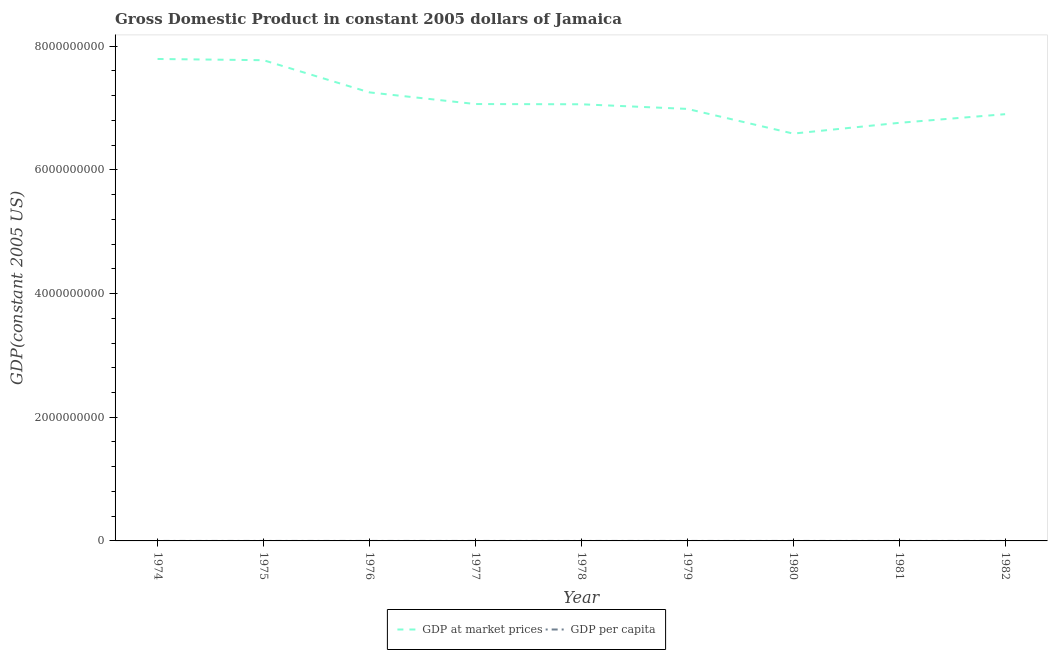Does the line corresponding to gdp at market prices intersect with the line corresponding to gdp per capita?
Provide a short and direct response. No. What is the gdp per capita in 1978?
Provide a succinct answer. 3393.74. Across all years, what is the maximum gdp at market prices?
Keep it short and to the point. 7.79e+09. Across all years, what is the minimum gdp at market prices?
Your answer should be very brief. 6.59e+09. In which year was the gdp at market prices maximum?
Make the answer very short. 1974. In which year was the gdp per capita minimum?
Make the answer very short. 1980. What is the total gdp per capita in the graph?
Keep it short and to the point. 3.08e+04. What is the difference between the gdp per capita in 1977 and that in 1978?
Offer a very short reply. 36.3. What is the difference between the gdp at market prices in 1981 and the gdp per capita in 1978?
Give a very brief answer. 6.76e+09. What is the average gdp at market prices per year?
Your response must be concise. 7.13e+09. In the year 1974, what is the difference between the gdp at market prices and gdp per capita?
Your response must be concise. 7.79e+09. In how many years, is the gdp at market prices greater than 7600000000 US$?
Your answer should be very brief. 2. What is the ratio of the gdp at market prices in 1977 to that in 1981?
Your answer should be compact. 1.04. Is the gdp per capita in 1977 less than that in 1979?
Provide a short and direct response. No. What is the difference between the highest and the second highest gdp per capita?
Your answer should be very brief. 62.83. What is the difference between the highest and the lowest gdp per capita?
Make the answer very short. 836.3. Is the sum of the gdp at market prices in 1976 and 1979 greater than the maximum gdp per capita across all years?
Offer a terse response. Yes. Does the gdp per capita monotonically increase over the years?
Your response must be concise. No. Is the gdp per capita strictly greater than the gdp at market prices over the years?
Offer a terse response. No. How many lines are there?
Make the answer very short. 2. What is the difference between two consecutive major ticks on the Y-axis?
Provide a short and direct response. 2.00e+09. Are the values on the major ticks of Y-axis written in scientific E-notation?
Provide a succinct answer. No. How are the legend labels stacked?
Offer a very short reply. Horizontal. What is the title of the graph?
Provide a succinct answer. Gross Domestic Product in constant 2005 dollars of Jamaica. What is the label or title of the X-axis?
Offer a terse response. Year. What is the label or title of the Y-axis?
Keep it short and to the point. GDP(constant 2005 US). What is the GDP(constant 2005 US) in GDP at market prices in 1974?
Your answer should be compact. 7.79e+09. What is the GDP(constant 2005 US) in GDP per capita in 1974?
Provide a succinct answer. 3923.99. What is the GDP(constant 2005 US) in GDP at market prices in 1975?
Provide a short and direct response. 7.77e+09. What is the GDP(constant 2005 US) of GDP per capita in 1975?
Your answer should be compact. 3861.15. What is the GDP(constant 2005 US) in GDP at market prices in 1976?
Provide a short and direct response. 7.25e+09. What is the GDP(constant 2005 US) in GDP per capita in 1976?
Keep it short and to the point. 3558.98. What is the GDP(constant 2005 US) of GDP at market prices in 1977?
Your answer should be compact. 7.06e+09. What is the GDP(constant 2005 US) of GDP per capita in 1977?
Provide a short and direct response. 3430.04. What is the GDP(constant 2005 US) in GDP at market prices in 1978?
Ensure brevity in your answer.  7.06e+09. What is the GDP(constant 2005 US) of GDP per capita in 1978?
Offer a terse response. 3393.74. What is the GDP(constant 2005 US) of GDP at market prices in 1979?
Your response must be concise. 6.99e+09. What is the GDP(constant 2005 US) in GDP per capita in 1979?
Provide a short and direct response. 3319.73. What is the GDP(constant 2005 US) of GDP at market prices in 1980?
Provide a succinct answer. 6.59e+09. What is the GDP(constant 2005 US) of GDP per capita in 1980?
Offer a terse response. 3087.69. What is the GDP(constant 2005 US) in GDP at market prices in 1981?
Keep it short and to the point. 6.76e+09. What is the GDP(constant 2005 US) in GDP per capita in 1981?
Your answer should be compact. 3126.24. What is the GDP(constant 2005 US) in GDP at market prices in 1982?
Offer a very short reply. 6.90e+09. What is the GDP(constant 2005 US) in GDP per capita in 1982?
Offer a very short reply. 3136.11. Across all years, what is the maximum GDP(constant 2005 US) of GDP at market prices?
Give a very brief answer. 7.79e+09. Across all years, what is the maximum GDP(constant 2005 US) of GDP per capita?
Your response must be concise. 3923.99. Across all years, what is the minimum GDP(constant 2005 US) in GDP at market prices?
Your response must be concise. 6.59e+09. Across all years, what is the minimum GDP(constant 2005 US) of GDP per capita?
Keep it short and to the point. 3087.69. What is the total GDP(constant 2005 US) of GDP at market prices in the graph?
Give a very brief answer. 6.42e+1. What is the total GDP(constant 2005 US) of GDP per capita in the graph?
Provide a short and direct response. 3.08e+04. What is the difference between the GDP(constant 2005 US) in GDP at market prices in 1974 and that in 1975?
Your answer should be very brief. 2.00e+07. What is the difference between the GDP(constant 2005 US) in GDP per capita in 1974 and that in 1975?
Provide a succinct answer. 62.83. What is the difference between the GDP(constant 2005 US) of GDP at market prices in 1974 and that in 1976?
Provide a succinct answer. 5.40e+08. What is the difference between the GDP(constant 2005 US) in GDP per capita in 1974 and that in 1976?
Your answer should be very brief. 365.01. What is the difference between the GDP(constant 2005 US) of GDP at market prices in 1974 and that in 1977?
Make the answer very short. 7.29e+08. What is the difference between the GDP(constant 2005 US) in GDP per capita in 1974 and that in 1977?
Keep it short and to the point. 493.95. What is the difference between the GDP(constant 2005 US) of GDP at market prices in 1974 and that in 1978?
Make the answer very short. 7.32e+08. What is the difference between the GDP(constant 2005 US) in GDP per capita in 1974 and that in 1978?
Offer a terse response. 530.25. What is the difference between the GDP(constant 2005 US) of GDP at market prices in 1974 and that in 1979?
Offer a terse response. 8.07e+08. What is the difference between the GDP(constant 2005 US) in GDP per capita in 1974 and that in 1979?
Your response must be concise. 604.26. What is the difference between the GDP(constant 2005 US) in GDP at market prices in 1974 and that in 1980?
Make the answer very short. 1.21e+09. What is the difference between the GDP(constant 2005 US) of GDP per capita in 1974 and that in 1980?
Ensure brevity in your answer.  836.3. What is the difference between the GDP(constant 2005 US) of GDP at market prices in 1974 and that in 1981?
Make the answer very short. 1.03e+09. What is the difference between the GDP(constant 2005 US) in GDP per capita in 1974 and that in 1981?
Provide a succinct answer. 797.75. What is the difference between the GDP(constant 2005 US) of GDP at market prices in 1974 and that in 1982?
Make the answer very short. 8.93e+08. What is the difference between the GDP(constant 2005 US) of GDP per capita in 1974 and that in 1982?
Your answer should be very brief. 787.88. What is the difference between the GDP(constant 2005 US) of GDP at market prices in 1975 and that in 1976?
Offer a very short reply. 5.20e+08. What is the difference between the GDP(constant 2005 US) in GDP per capita in 1975 and that in 1976?
Ensure brevity in your answer.  302.17. What is the difference between the GDP(constant 2005 US) of GDP at market prices in 1975 and that in 1977?
Ensure brevity in your answer.  7.09e+08. What is the difference between the GDP(constant 2005 US) of GDP per capita in 1975 and that in 1977?
Provide a succinct answer. 431.12. What is the difference between the GDP(constant 2005 US) of GDP at market prices in 1975 and that in 1978?
Make the answer very short. 7.12e+08. What is the difference between the GDP(constant 2005 US) of GDP per capita in 1975 and that in 1978?
Provide a succinct answer. 467.41. What is the difference between the GDP(constant 2005 US) in GDP at market prices in 1975 and that in 1979?
Provide a succinct answer. 7.87e+08. What is the difference between the GDP(constant 2005 US) of GDP per capita in 1975 and that in 1979?
Provide a short and direct response. 541.42. What is the difference between the GDP(constant 2005 US) in GDP at market prices in 1975 and that in 1980?
Your response must be concise. 1.19e+09. What is the difference between the GDP(constant 2005 US) of GDP per capita in 1975 and that in 1980?
Provide a succinct answer. 773.47. What is the difference between the GDP(constant 2005 US) of GDP at market prices in 1975 and that in 1981?
Offer a very short reply. 1.01e+09. What is the difference between the GDP(constant 2005 US) in GDP per capita in 1975 and that in 1981?
Your response must be concise. 734.91. What is the difference between the GDP(constant 2005 US) of GDP at market prices in 1975 and that in 1982?
Make the answer very short. 8.73e+08. What is the difference between the GDP(constant 2005 US) of GDP per capita in 1975 and that in 1982?
Your response must be concise. 725.05. What is the difference between the GDP(constant 2005 US) in GDP at market prices in 1976 and that in 1977?
Offer a very short reply. 1.88e+08. What is the difference between the GDP(constant 2005 US) in GDP per capita in 1976 and that in 1977?
Provide a short and direct response. 128.94. What is the difference between the GDP(constant 2005 US) in GDP at market prices in 1976 and that in 1978?
Provide a succinct answer. 1.92e+08. What is the difference between the GDP(constant 2005 US) in GDP per capita in 1976 and that in 1978?
Offer a very short reply. 165.24. What is the difference between the GDP(constant 2005 US) of GDP at market prices in 1976 and that in 1979?
Your response must be concise. 2.67e+08. What is the difference between the GDP(constant 2005 US) of GDP per capita in 1976 and that in 1979?
Offer a very short reply. 239.25. What is the difference between the GDP(constant 2005 US) in GDP at market prices in 1976 and that in 1980?
Your answer should be compact. 6.66e+08. What is the difference between the GDP(constant 2005 US) of GDP per capita in 1976 and that in 1980?
Provide a short and direct response. 471.29. What is the difference between the GDP(constant 2005 US) in GDP at market prices in 1976 and that in 1981?
Your answer should be compact. 4.92e+08. What is the difference between the GDP(constant 2005 US) in GDP per capita in 1976 and that in 1981?
Make the answer very short. 432.74. What is the difference between the GDP(constant 2005 US) of GDP at market prices in 1976 and that in 1982?
Give a very brief answer. 3.52e+08. What is the difference between the GDP(constant 2005 US) of GDP per capita in 1976 and that in 1982?
Make the answer very short. 422.87. What is the difference between the GDP(constant 2005 US) of GDP at market prices in 1977 and that in 1978?
Make the answer very short. 3.79e+06. What is the difference between the GDP(constant 2005 US) of GDP per capita in 1977 and that in 1978?
Make the answer very short. 36.3. What is the difference between the GDP(constant 2005 US) in GDP at market prices in 1977 and that in 1979?
Your answer should be very brief. 7.86e+07. What is the difference between the GDP(constant 2005 US) of GDP per capita in 1977 and that in 1979?
Offer a very short reply. 110.31. What is the difference between the GDP(constant 2005 US) in GDP at market prices in 1977 and that in 1980?
Ensure brevity in your answer.  4.78e+08. What is the difference between the GDP(constant 2005 US) in GDP per capita in 1977 and that in 1980?
Make the answer very short. 342.35. What is the difference between the GDP(constant 2005 US) in GDP at market prices in 1977 and that in 1981?
Offer a very short reply. 3.04e+08. What is the difference between the GDP(constant 2005 US) in GDP per capita in 1977 and that in 1981?
Make the answer very short. 303.8. What is the difference between the GDP(constant 2005 US) of GDP at market prices in 1977 and that in 1982?
Provide a short and direct response. 1.64e+08. What is the difference between the GDP(constant 2005 US) in GDP per capita in 1977 and that in 1982?
Make the answer very short. 293.93. What is the difference between the GDP(constant 2005 US) in GDP at market prices in 1978 and that in 1979?
Ensure brevity in your answer.  7.48e+07. What is the difference between the GDP(constant 2005 US) in GDP per capita in 1978 and that in 1979?
Your answer should be very brief. 74.01. What is the difference between the GDP(constant 2005 US) in GDP at market prices in 1978 and that in 1980?
Your answer should be compact. 4.74e+08. What is the difference between the GDP(constant 2005 US) of GDP per capita in 1978 and that in 1980?
Provide a short and direct response. 306.05. What is the difference between the GDP(constant 2005 US) in GDP at market prices in 1978 and that in 1981?
Provide a short and direct response. 3.00e+08. What is the difference between the GDP(constant 2005 US) of GDP per capita in 1978 and that in 1981?
Provide a succinct answer. 267.5. What is the difference between the GDP(constant 2005 US) in GDP at market prices in 1978 and that in 1982?
Offer a terse response. 1.60e+08. What is the difference between the GDP(constant 2005 US) in GDP per capita in 1978 and that in 1982?
Your answer should be compact. 257.63. What is the difference between the GDP(constant 2005 US) of GDP at market prices in 1979 and that in 1980?
Offer a very short reply. 3.99e+08. What is the difference between the GDP(constant 2005 US) of GDP per capita in 1979 and that in 1980?
Your response must be concise. 232.04. What is the difference between the GDP(constant 2005 US) of GDP at market prices in 1979 and that in 1981?
Your response must be concise. 2.25e+08. What is the difference between the GDP(constant 2005 US) in GDP per capita in 1979 and that in 1981?
Offer a very short reply. 193.49. What is the difference between the GDP(constant 2005 US) of GDP at market prices in 1979 and that in 1982?
Offer a terse response. 8.54e+07. What is the difference between the GDP(constant 2005 US) in GDP per capita in 1979 and that in 1982?
Give a very brief answer. 183.62. What is the difference between the GDP(constant 2005 US) of GDP at market prices in 1980 and that in 1981?
Keep it short and to the point. -1.74e+08. What is the difference between the GDP(constant 2005 US) in GDP per capita in 1980 and that in 1981?
Offer a very short reply. -38.55. What is the difference between the GDP(constant 2005 US) in GDP at market prices in 1980 and that in 1982?
Your response must be concise. -3.14e+08. What is the difference between the GDP(constant 2005 US) of GDP per capita in 1980 and that in 1982?
Offer a very short reply. -48.42. What is the difference between the GDP(constant 2005 US) in GDP at market prices in 1981 and that in 1982?
Keep it short and to the point. -1.40e+08. What is the difference between the GDP(constant 2005 US) of GDP per capita in 1981 and that in 1982?
Provide a short and direct response. -9.87. What is the difference between the GDP(constant 2005 US) of GDP at market prices in 1974 and the GDP(constant 2005 US) of GDP per capita in 1975?
Your answer should be very brief. 7.79e+09. What is the difference between the GDP(constant 2005 US) of GDP at market prices in 1974 and the GDP(constant 2005 US) of GDP per capita in 1976?
Provide a short and direct response. 7.79e+09. What is the difference between the GDP(constant 2005 US) in GDP at market prices in 1974 and the GDP(constant 2005 US) in GDP per capita in 1977?
Give a very brief answer. 7.79e+09. What is the difference between the GDP(constant 2005 US) in GDP at market prices in 1974 and the GDP(constant 2005 US) in GDP per capita in 1978?
Your answer should be compact. 7.79e+09. What is the difference between the GDP(constant 2005 US) of GDP at market prices in 1974 and the GDP(constant 2005 US) of GDP per capita in 1979?
Offer a terse response. 7.79e+09. What is the difference between the GDP(constant 2005 US) of GDP at market prices in 1974 and the GDP(constant 2005 US) of GDP per capita in 1980?
Your answer should be very brief. 7.79e+09. What is the difference between the GDP(constant 2005 US) of GDP at market prices in 1974 and the GDP(constant 2005 US) of GDP per capita in 1981?
Ensure brevity in your answer.  7.79e+09. What is the difference between the GDP(constant 2005 US) in GDP at market prices in 1974 and the GDP(constant 2005 US) in GDP per capita in 1982?
Make the answer very short. 7.79e+09. What is the difference between the GDP(constant 2005 US) in GDP at market prices in 1975 and the GDP(constant 2005 US) in GDP per capita in 1976?
Make the answer very short. 7.77e+09. What is the difference between the GDP(constant 2005 US) in GDP at market prices in 1975 and the GDP(constant 2005 US) in GDP per capita in 1977?
Keep it short and to the point. 7.77e+09. What is the difference between the GDP(constant 2005 US) in GDP at market prices in 1975 and the GDP(constant 2005 US) in GDP per capita in 1978?
Provide a succinct answer. 7.77e+09. What is the difference between the GDP(constant 2005 US) in GDP at market prices in 1975 and the GDP(constant 2005 US) in GDP per capita in 1979?
Offer a very short reply. 7.77e+09. What is the difference between the GDP(constant 2005 US) in GDP at market prices in 1975 and the GDP(constant 2005 US) in GDP per capita in 1980?
Your answer should be compact. 7.77e+09. What is the difference between the GDP(constant 2005 US) of GDP at market prices in 1975 and the GDP(constant 2005 US) of GDP per capita in 1981?
Your response must be concise. 7.77e+09. What is the difference between the GDP(constant 2005 US) in GDP at market prices in 1975 and the GDP(constant 2005 US) in GDP per capita in 1982?
Provide a succinct answer. 7.77e+09. What is the difference between the GDP(constant 2005 US) of GDP at market prices in 1976 and the GDP(constant 2005 US) of GDP per capita in 1977?
Ensure brevity in your answer.  7.25e+09. What is the difference between the GDP(constant 2005 US) of GDP at market prices in 1976 and the GDP(constant 2005 US) of GDP per capita in 1978?
Make the answer very short. 7.25e+09. What is the difference between the GDP(constant 2005 US) of GDP at market prices in 1976 and the GDP(constant 2005 US) of GDP per capita in 1979?
Your response must be concise. 7.25e+09. What is the difference between the GDP(constant 2005 US) in GDP at market prices in 1976 and the GDP(constant 2005 US) in GDP per capita in 1980?
Provide a succinct answer. 7.25e+09. What is the difference between the GDP(constant 2005 US) of GDP at market prices in 1976 and the GDP(constant 2005 US) of GDP per capita in 1981?
Provide a succinct answer. 7.25e+09. What is the difference between the GDP(constant 2005 US) of GDP at market prices in 1976 and the GDP(constant 2005 US) of GDP per capita in 1982?
Your answer should be compact. 7.25e+09. What is the difference between the GDP(constant 2005 US) in GDP at market prices in 1977 and the GDP(constant 2005 US) in GDP per capita in 1978?
Offer a terse response. 7.06e+09. What is the difference between the GDP(constant 2005 US) in GDP at market prices in 1977 and the GDP(constant 2005 US) in GDP per capita in 1979?
Keep it short and to the point. 7.06e+09. What is the difference between the GDP(constant 2005 US) in GDP at market prices in 1977 and the GDP(constant 2005 US) in GDP per capita in 1980?
Your answer should be very brief. 7.06e+09. What is the difference between the GDP(constant 2005 US) of GDP at market prices in 1977 and the GDP(constant 2005 US) of GDP per capita in 1981?
Your answer should be very brief. 7.06e+09. What is the difference between the GDP(constant 2005 US) in GDP at market prices in 1977 and the GDP(constant 2005 US) in GDP per capita in 1982?
Provide a succinct answer. 7.06e+09. What is the difference between the GDP(constant 2005 US) in GDP at market prices in 1978 and the GDP(constant 2005 US) in GDP per capita in 1979?
Make the answer very short. 7.06e+09. What is the difference between the GDP(constant 2005 US) of GDP at market prices in 1978 and the GDP(constant 2005 US) of GDP per capita in 1980?
Give a very brief answer. 7.06e+09. What is the difference between the GDP(constant 2005 US) in GDP at market prices in 1978 and the GDP(constant 2005 US) in GDP per capita in 1981?
Your answer should be compact. 7.06e+09. What is the difference between the GDP(constant 2005 US) of GDP at market prices in 1978 and the GDP(constant 2005 US) of GDP per capita in 1982?
Keep it short and to the point. 7.06e+09. What is the difference between the GDP(constant 2005 US) of GDP at market prices in 1979 and the GDP(constant 2005 US) of GDP per capita in 1980?
Your answer should be very brief. 6.99e+09. What is the difference between the GDP(constant 2005 US) of GDP at market prices in 1979 and the GDP(constant 2005 US) of GDP per capita in 1981?
Provide a succinct answer. 6.99e+09. What is the difference between the GDP(constant 2005 US) in GDP at market prices in 1979 and the GDP(constant 2005 US) in GDP per capita in 1982?
Your response must be concise. 6.99e+09. What is the difference between the GDP(constant 2005 US) in GDP at market prices in 1980 and the GDP(constant 2005 US) in GDP per capita in 1981?
Provide a succinct answer. 6.59e+09. What is the difference between the GDP(constant 2005 US) in GDP at market prices in 1980 and the GDP(constant 2005 US) in GDP per capita in 1982?
Keep it short and to the point. 6.59e+09. What is the difference between the GDP(constant 2005 US) in GDP at market prices in 1981 and the GDP(constant 2005 US) in GDP per capita in 1982?
Your response must be concise. 6.76e+09. What is the average GDP(constant 2005 US) of GDP at market prices per year?
Your answer should be very brief. 7.13e+09. What is the average GDP(constant 2005 US) of GDP per capita per year?
Offer a very short reply. 3426.41. In the year 1974, what is the difference between the GDP(constant 2005 US) in GDP at market prices and GDP(constant 2005 US) in GDP per capita?
Provide a succinct answer. 7.79e+09. In the year 1975, what is the difference between the GDP(constant 2005 US) in GDP at market prices and GDP(constant 2005 US) in GDP per capita?
Offer a terse response. 7.77e+09. In the year 1976, what is the difference between the GDP(constant 2005 US) of GDP at market prices and GDP(constant 2005 US) of GDP per capita?
Offer a very short reply. 7.25e+09. In the year 1977, what is the difference between the GDP(constant 2005 US) of GDP at market prices and GDP(constant 2005 US) of GDP per capita?
Your answer should be compact. 7.06e+09. In the year 1978, what is the difference between the GDP(constant 2005 US) in GDP at market prices and GDP(constant 2005 US) in GDP per capita?
Provide a succinct answer. 7.06e+09. In the year 1979, what is the difference between the GDP(constant 2005 US) of GDP at market prices and GDP(constant 2005 US) of GDP per capita?
Your answer should be very brief. 6.99e+09. In the year 1980, what is the difference between the GDP(constant 2005 US) in GDP at market prices and GDP(constant 2005 US) in GDP per capita?
Keep it short and to the point. 6.59e+09. In the year 1981, what is the difference between the GDP(constant 2005 US) of GDP at market prices and GDP(constant 2005 US) of GDP per capita?
Provide a short and direct response. 6.76e+09. In the year 1982, what is the difference between the GDP(constant 2005 US) of GDP at market prices and GDP(constant 2005 US) of GDP per capita?
Offer a very short reply. 6.90e+09. What is the ratio of the GDP(constant 2005 US) in GDP at market prices in 1974 to that in 1975?
Ensure brevity in your answer.  1. What is the ratio of the GDP(constant 2005 US) of GDP per capita in 1974 to that in 1975?
Your response must be concise. 1.02. What is the ratio of the GDP(constant 2005 US) in GDP at market prices in 1974 to that in 1976?
Give a very brief answer. 1.07. What is the ratio of the GDP(constant 2005 US) of GDP per capita in 1974 to that in 1976?
Your response must be concise. 1.1. What is the ratio of the GDP(constant 2005 US) of GDP at market prices in 1974 to that in 1977?
Ensure brevity in your answer.  1.1. What is the ratio of the GDP(constant 2005 US) in GDP per capita in 1974 to that in 1977?
Provide a succinct answer. 1.14. What is the ratio of the GDP(constant 2005 US) of GDP at market prices in 1974 to that in 1978?
Offer a terse response. 1.1. What is the ratio of the GDP(constant 2005 US) in GDP per capita in 1974 to that in 1978?
Make the answer very short. 1.16. What is the ratio of the GDP(constant 2005 US) of GDP at market prices in 1974 to that in 1979?
Your answer should be compact. 1.12. What is the ratio of the GDP(constant 2005 US) in GDP per capita in 1974 to that in 1979?
Your answer should be very brief. 1.18. What is the ratio of the GDP(constant 2005 US) in GDP at market prices in 1974 to that in 1980?
Make the answer very short. 1.18. What is the ratio of the GDP(constant 2005 US) in GDP per capita in 1974 to that in 1980?
Keep it short and to the point. 1.27. What is the ratio of the GDP(constant 2005 US) of GDP at market prices in 1974 to that in 1981?
Make the answer very short. 1.15. What is the ratio of the GDP(constant 2005 US) in GDP per capita in 1974 to that in 1981?
Offer a very short reply. 1.26. What is the ratio of the GDP(constant 2005 US) of GDP at market prices in 1974 to that in 1982?
Your response must be concise. 1.13. What is the ratio of the GDP(constant 2005 US) in GDP per capita in 1974 to that in 1982?
Your answer should be compact. 1.25. What is the ratio of the GDP(constant 2005 US) in GDP at market prices in 1975 to that in 1976?
Ensure brevity in your answer.  1.07. What is the ratio of the GDP(constant 2005 US) in GDP per capita in 1975 to that in 1976?
Make the answer very short. 1.08. What is the ratio of the GDP(constant 2005 US) in GDP at market prices in 1975 to that in 1977?
Your response must be concise. 1.1. What is the ratio of the GDP(constant 2005 US) of GDP per capita in 1975 to that in 1977?
Make the answer very short. 1.13. What is the ratio of the GDP(constant 2005 US) of GDP at market prices in 1975 to that in 1978?
Your response must be concise. 1.1. What is the ratio of the GDP(constant 2005 US) in GDP per capita in 1975 to that in 1978?
Ensure brevity in your answer.  1.14. What is the ratio of the GDP(constant 2005 US) of GDP at market prices in 1975 to that in 1979?
Provide a short and direct response. 1.11. What is the ratio of the GDP(constant 2005 US) of GDP per capita in 1975 to that in 1979?
Your answer should be compact. 1.16. What is the ratio of the GDP(constant 2005 US) of GDP at market prices in 1975 to that in 1980?
Make the answer very short. 1.18. What is the ratio of the GDP(constant 2005 US) in GDP per capita in 1975 to that in 1980?
Offer a very short reply. 1.25. What is the ratio of the GDP(constant 2005 US) in GDP at market prices in 1975 to that in 1981?
Your answer should be very brief. 1.15. What is the ratio of the GDP(constant 2005 US) of GDP per capita in 1975 to that in 1981?
Offer a very short reply. 1.24. What is the ratio of the GDP(constant 2005 US) in GDP at market prices in 1975 to that in 1982?
Your response must be concise. 1.13. What is the ratio of the GDP(constant 2005 US) in GDP per capita in 1975 to that in 1982?
Your response must be concise. 1.23. What is the ratio of the GDP(constant 2005 US) in GDP at market prices in 1976 to that in 1977?
Ensure brevity in your answer.  1.03. What is the ratio of the GDP(constant 2005 US) in GDP per capita in 1976 to that in 1977?
Your answer should be very brief. 1.04. What is the ratio of the GDP(constant 2005 US) in GDP at market prices in 1976 to that in 1978?
Keep it short and to the point. 1.03. What is the ratio of the GDP(constant 2005 US) of GDP per capita in 1976 to that in 1978?
Make the answer very short. 1.05. What is the ratio of the GDP(constant 2005 US) in GDP at market prices in 1976 to that in 1979?
Offer a very short reply. 1.04. What is the ratio of the GDP(constant 2005 US) of GDP per capita in 1976 to that in 1979?
Ensure brevity in your answer.  1.07. What is the ratio of the GDP(constant 2005 US) in GDP at market prices in 1976 to that in 1980?
Provide a short and direct response. 1.1. What is the ratio of the GDP(constant 2005 US) in GDP per capita in 1976 to that in 1980?
Give a very brief answer. 1.15. What is the ratio of the GDP(constant 2005 US) of GDP at market prices in 1976 to that in 1981?
Give a very brief answer. 1.07. What is the ratio of the GDP(constant 2005 US) in GDP per capita in 1976 to that in 1981?
Provide a succinct answer. 1.14. What is the ratio of the GDP(constant 2005 US) in GDP at market prices in 1976 to that in 1982?
Your answer should be compact. 1.05. What is the ratio of the GDP(constant 2005 US) in GDP per capita in 1976 to that in 1982?
Ensure brevity in your answer.  1.13. What is the ratio of the GDP(constant 2005 US) in GDP at market prices in 1977 to that in 1978?
Provide a short and direct response. 1. What is the ratio of the GDP(constant 2005 US) of GDP per capita in 1977 to that in 1978?
Offer a terse response. 1.01. What is the ratio of the GDP(constant 2005 US) of GDP at market prices in 1977 to that in 1979?
Your answer should be compact. 1.01. What is the ratio of the GDP(constant 2005 US) of GDP per capita in 1977 to that in 1979?
Offer a very short reply. 1.03. What is the ratio of the GDP(constant 2005 US) in GDP at market prices in 1977 to that in 1980?
Provide a short and direct response. 1.07. What is the ratio of the GDP(constant 2005 US) in GDP per capita in 1977 to that in 1980?
Keep it short and to the point. 1.11. What is the ratio of the GDP(constant 2005 US) in GDP at market prices in 1977 to that in 1981?
Provide a succinct answer. 1.04. What is the ratio of the GDP(constant 2005 US) in GDP per capita in 1977 to that in 1981?
Your answer should be compact. 1.1. What is the ratio of the GDP(constant 2005 US) of GDP at market prices in 1977 to that in 1982?
Provide a short and direct response. 1.02. What is the ratio of the GDP(constant 2005 US) of GDP per capita in 1977 to that in 1982?
Make the answer very short. 1.09. What is the ratio of the GDP(constant 2005 US) of GDP at market prices in 1978 to that in 1979?
Give a very brief answer. 1.01. What is the ratio of the GDP(constant 2005 US) of GDP per capita in 1978 to that in 1979?
Make the answer very short. 1.02. What is the ratio of the GDP(constant 2005 US) in GDP at market prices in 1978 to that in 1980?
Ensure brevity in your answer.  1.07. What is the ratio of the GDP(constant 2005 US) in GDP per capita in 1978 to that in 1980?
Your response must be concise. 1.1. What is the ratio of the GDP(constant 2005 US) in GDP at market prices in 1978 to that in 1981?
Give a very brief answer. 1.04. What is the ratio of the GDP(constant 2005 US) in GDP per capita in 1978 to that in 1981?
Provide a succinct answer. 1.09. What is the ratio of the GDP(constant 2005 US) in GDP at market prices in 1978 to that in 1982?
Offer a terse response. 1.02. What is the ratio of the GDP(constant 2005 US) of GDP per capita in 1978 to that in 1982?
Your answer should be compact. 1.08. What is the ratio of the GDP(constant 2005 US) in GDP at market prices in 1979 to that in 1980?
Make the answer very short. 1.06. What is the ratio of the GDP(constant 2005 US) in GDP per capita in 1979 to that in 1980?
Offer a very short reply. 1.08. What is the ratio of the GDP(constant 2005 US) in GDP per capita in 1979 to that in 1981?
Make the answer very short. 1.06. What is the ratio of the GDP(constant 2005 US) of GDP at market prices in 1979 to that in 1982?
Provide a succinct answer. 1.01. What is the ratio of the GDP(constant 2005 US) in GDP per capita in 1979 to that in 1982?
Make the answer very short. 1.06. What is the ratio of the GDP(constant 2005 US) of GDP at market prices in 1980 to that in 1981?
Your answer should be very brief. 0.97. What is the ratio of the GDP(constant 2005 US) of GDP at market prices in 1980 to that in 1982?
Your answer should be very brief. 0.95. What is the ratio of the GDP(constant 2005 US) in GDP per capita in 1980 to that in 1982?
Your response must be concise. 0.98. What is the ratio of the GDP(constant 2005 US) in GDP at market prices in 1981 to that in 1982?
Give a very brief answer. 0.98. What is the ratio of the GDP(constant 2005 US) of GDP per capita in 1981 to that in 1982?
Offer a very short reply. 1. What is the difference between the highest and the second highest GDP(constant 2005 US) in GDP at market prices?
Offer a very short reply. 2.00e+07. What is the difference between the highest and the second highest GDP(constant 2005 US) of GDP per capita?
Your answer should be very brief. 62.83. What is the difference between the highest and the lowest GDP(constant 2005 US) in GDP at market prices?
Offer a very short reply. 1.21e+09. What is the difference between the highest and the lowest GDP(constant 2005 US) in GDP per capita?
Ensure brevity in your answer.  836.3. 